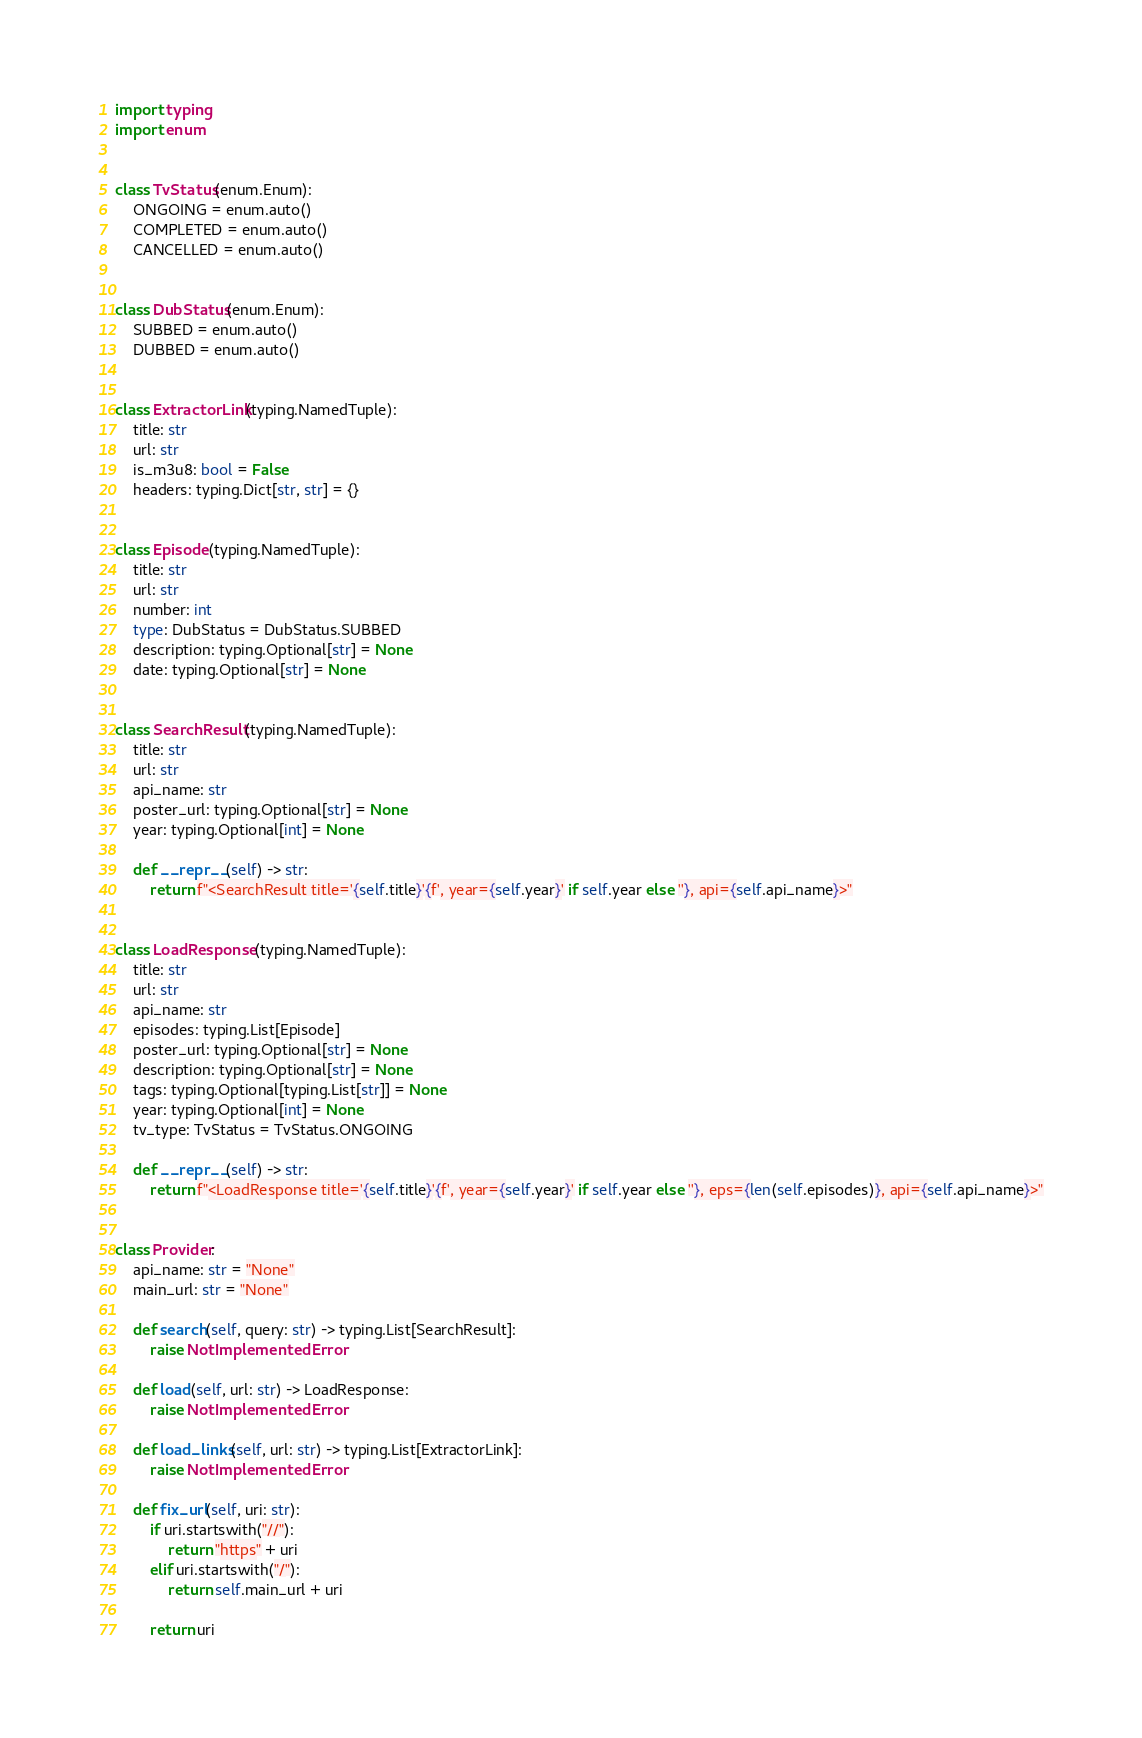<code> <loc_0><loc_0><loc_500><loc_500><_Python_>import typing
import enum


class TvStatus(enum.Enum):
    ONGOING = enum.auto()
    COMPLETED = enum.auto()
    CANCELLED = enum.auto()


class DubStatus(enum.Enum):
    SUBBED = enum.auto()
    DUBBED = enum.auto()


class ExtractorLink(typing.NamedTuple):
    title: str
    url: str
    is_m3u8: bool = False
    headers: typing.Dict[str, str] = {}


class Episode(typing.NamedTuple):
    title: str
    url: str
    number: int
    type: DubStatus = DubStatus.SUBBED
    description: typing.Optional[str] = None
    date: typing.Optional[str] = None


class SearchResult(typing.NamedTuple):
    title: str
    url: str
    api_name: str
    poster_url: typing.Optional[str] = None
    year: typing.Optional[int] = None

    def __repr__(self) -> str:
        return f"<SearchResult title='{self.title}'{f', year={self.year}' if self.year else ''}, api={self.api_name}>"


class LoadResponse(typing.NamedTuple):
    title: str
    url: str
    api_name: str
    episodes: typing.List[Episode]
    poster_url: typing.Optional[str] = None
    description: typing.Optional[str] = None
    tags: typing.Optional[typing.List[str]] = None
    year: typing.Optional[int] = None
    tv_type: TvStatus = TvStatus.ONGOING

    def __repr__(self) -> str:
        return f"<LoadResponse title='{self.title}'{f', year={self.year}' if self.year else ''}, eps={len(self.episodes)}, api={self.api_name}>"


class Provider:
    api_name: str = "None"
    main_url: str = "None"

    def search(self, query: str) -> typing.List[SearchResult]:
        raise NotImplementedError

    def load(self, url: str) -> LoadResponse:
        raise NotImplementedError

    def load_links(self, url: str) -> typing.List[ExtractorLink]:
        raise NotImplementedError

    def fix_url(self, uri: str):
        if uri.startswith("//"):
            return "https" + uri
        elif uri.startswith("/"):
            return self.main_url + uri

        return uri
</code> 